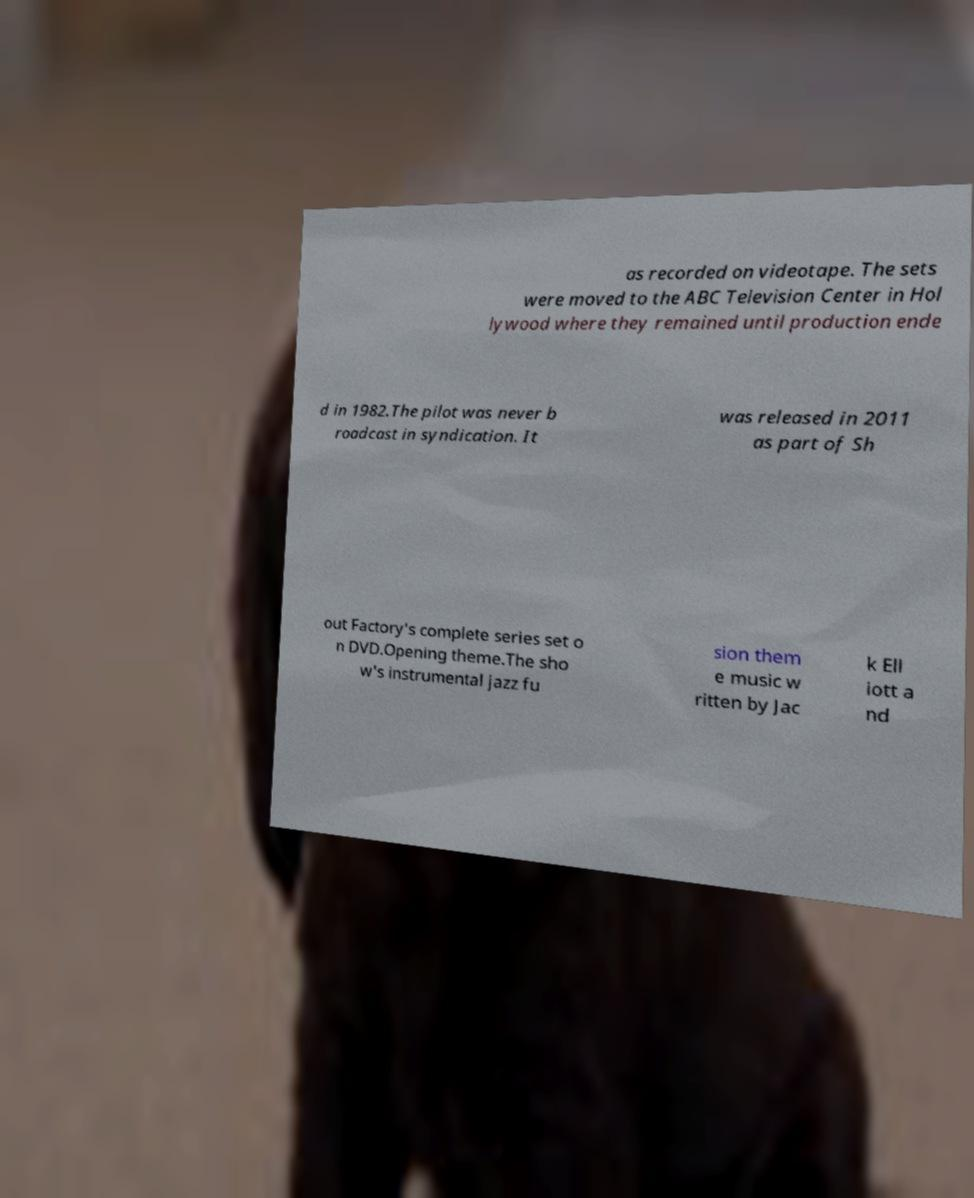Could you extract and type out the text from this image? as recorded on videotape. The sets were moved to the ABC Television Center in Hol lywood where they remained until production ende d in 1982.The pilot was never b roadcast in syndication. It was released in 2011 as part of Sh out Factory's complete series set o n DVD.Opening theme.The sho w's instrumental jazz fu sion them e music w ritten by Jac k Ell iott a nd 